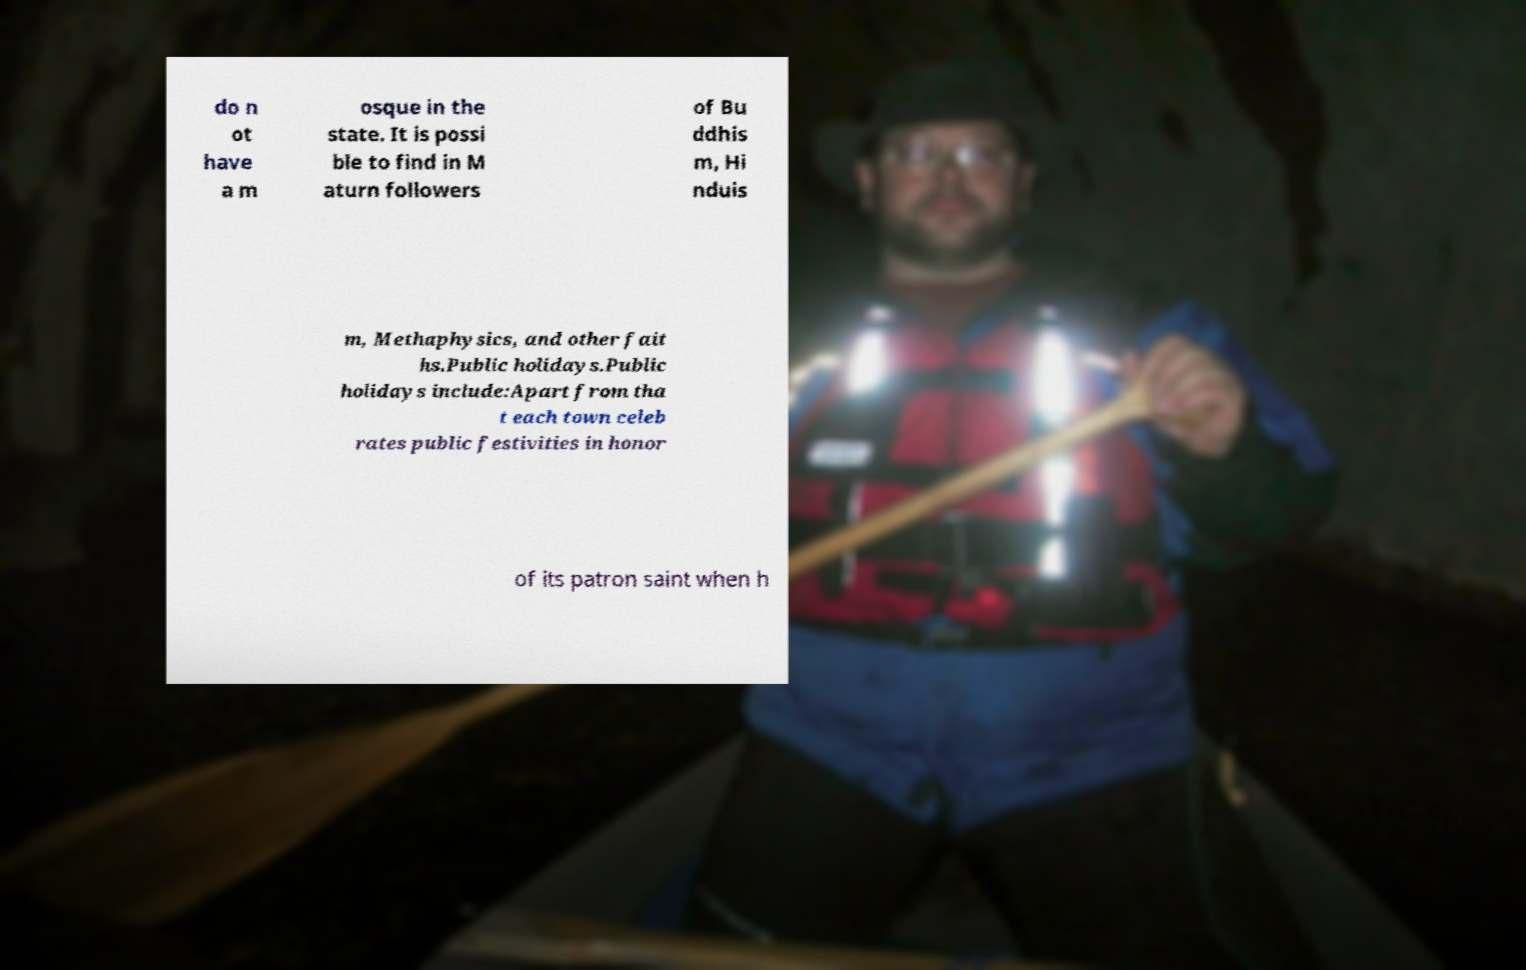There's text embedded in this image that I need extracted. Can you transcribe it verbatim? do n ot have a m osque in the state. It is possi ble to find in M aturn followers of Bu ddhis m, Hi nduis m, Methaphysics, and other fait hs.Public holidays.Public holidays include:Apart from tha t each town celeb rates public festivities in honor of its patron saint when h 